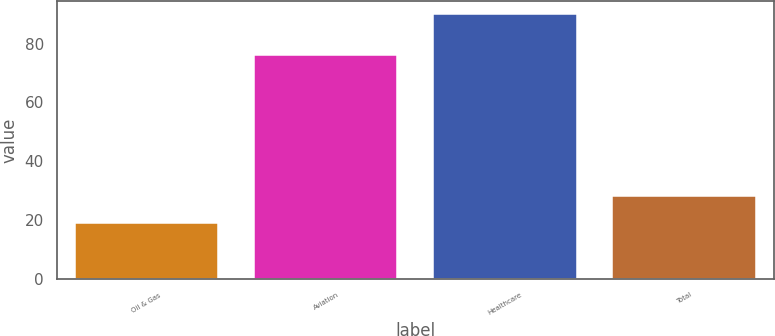Convert chart. <chart><loc_0><loc_0><loc_500><loc_500><bar_chart><fcel>Oil & Gas<fcel>Aviation<fcel>Healthcare<fcel>Total<nl><fcel>19<fcel>76<fcel>90<fcel>28<nl></chart> 